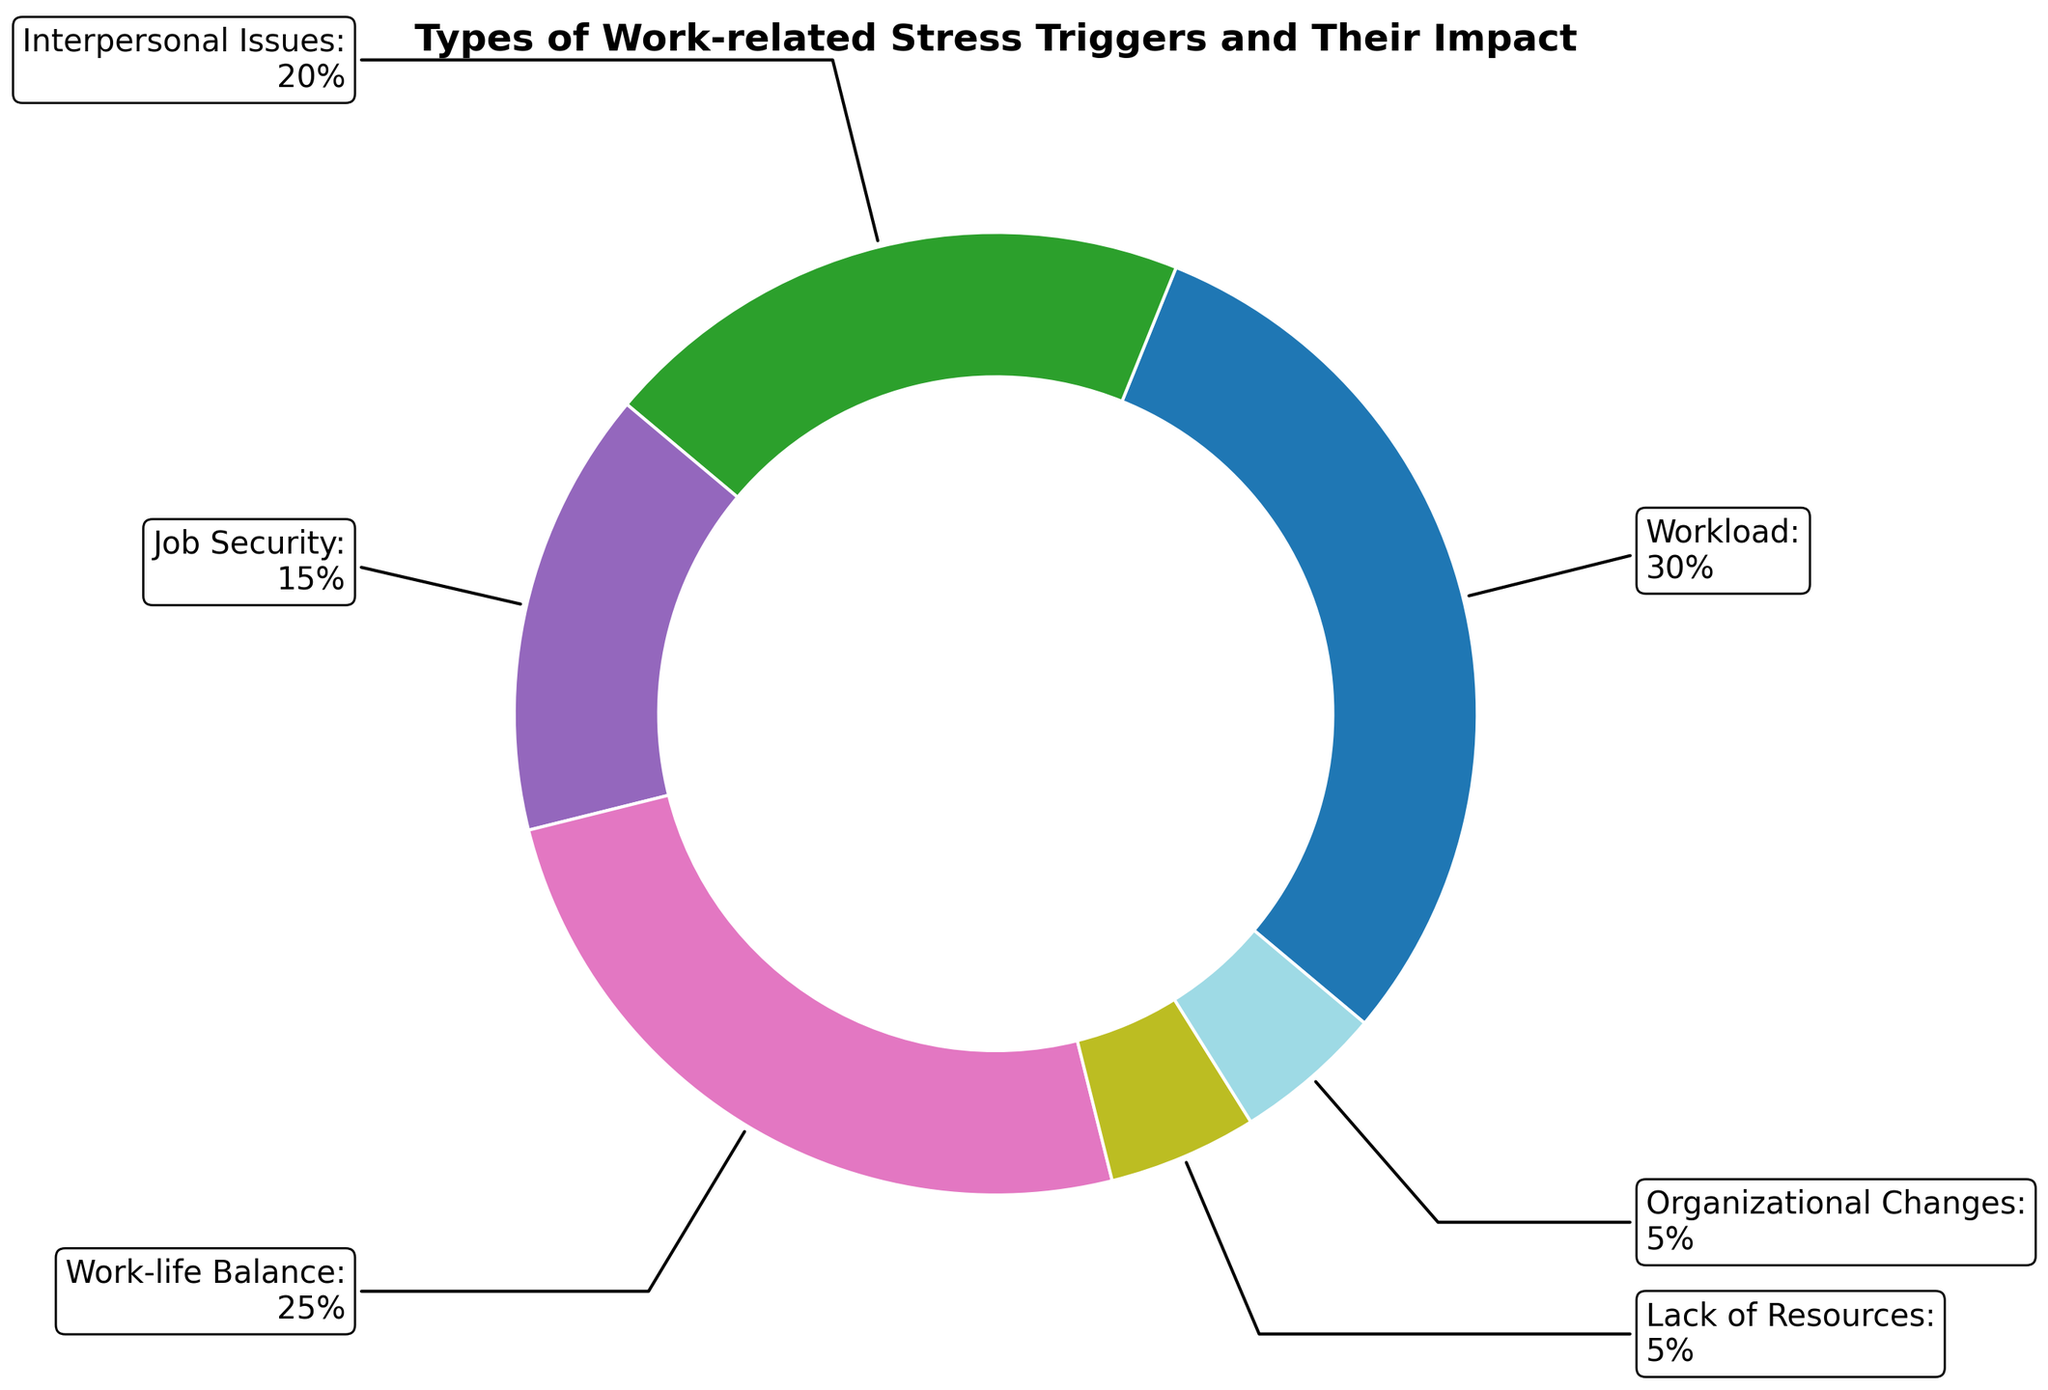Which stress trigger has the highest impact? The figure shows a ring chart with percentages indicating the impact of different work-related stress triggers. To find the highest impact, we look for the largest percentage.
Answer: Workload Which two stress triggers combined make up 50% of the total impact? To find two triggers that together sum up to 50%, we look at their percentages. Workload is 30% and Work-life Balance is 25%. Adding these gives us 55%. We look for another combination. Workload (30%) and Interpersonal Issues (20%) together make 50%.
Answer: Workload and Interpersonal Issues What is the difference in impact between Work-Life Balance and Job Security? Work-life Balance has an impact of 25%, and Job Security has an impact of 15%. Subtracting these gives us the difference. 25% - 15% = 10%.
Answer: 10% Which stress trigger has the lowest impact, and what is its percentage? Look for the smallest percentage in the ring chart. Both Lack of Resources and Organizational Changes have the smallest percentage at 5%.
Answer: Lack of Resources and Organizational Changes at 5% List the stress triggers with an impact greater than 20%. Identify the stress triggers with percentages greater than 20%. Workload at 30% and Work-life Balance at 25% meet this criterion.
Answer: Workload and Work-life Balance If we sum the impact of Lack of Resources and Organizational Changes, does it exceed 10%? Lack of Resources is at 5%, and Organizational Changes is also at 5%. Summing these gives us 5% + 5% = 10%, which does not exceed 10%.
Answer: No Which stress trigger, identifiable by its visual segment's size, has an impact between 10% and 20%? The trigger with a segment size that falls within 10% to 20% is Job Security, which has an impact of 15%.
Answer: Job Security How many stress triggers have less impact than Work-life Balance? Work-life Balance has an impact of 25%. We look for triggers with lower percentages: Interpersonal Issues (20%), Job Security (15%), Lack of Resources (5%), and Organizational Changes (5%). Four triggers are less than Work-life Balance.
Answer: Four What percentage of the impact is attributed to triggers related to organizational structure (Job Security and Organizational Changes)? Job Security has 15%, and Organizational Changes have 5%. Adding these gives us 20%.
Answer: 20% Compare the impact of Workload and Interpersonal Issues. Which has the higher impact, and by how much? Workload has an impact of 30%, and Interpersonal Issues have 20%. The difference is 30% - 20% = 10%.
Answer: Workload by 10% 